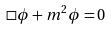Convert formula to latex. <formula><loc_0><loc_0><loc_500><loc_500>\square \phi + m ^ { 2 } \phi = 0</formula> 